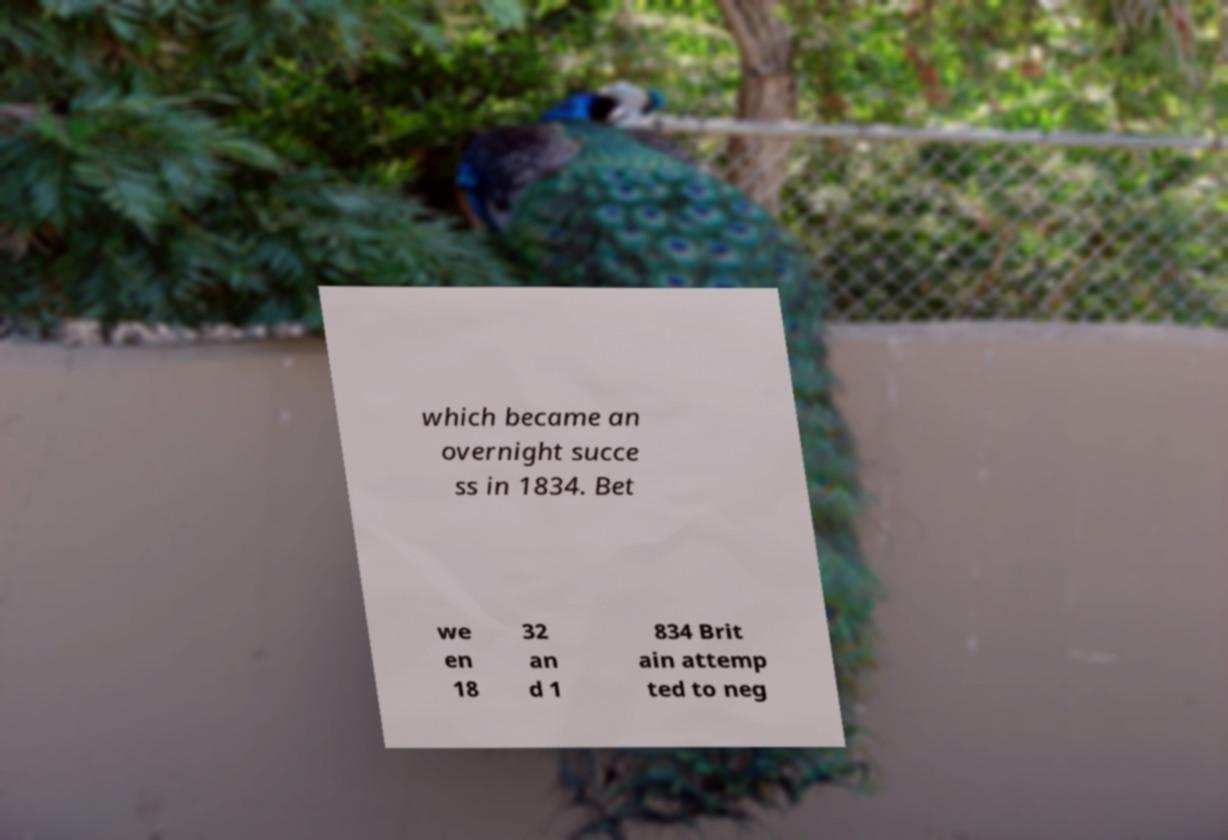What messages or text are displayed in this image? I need them in a readable, typed format. which became an overnight succe ss in 1834. Bet we en 18 32 an d 1 834 Brit ain attemp ted to neg 